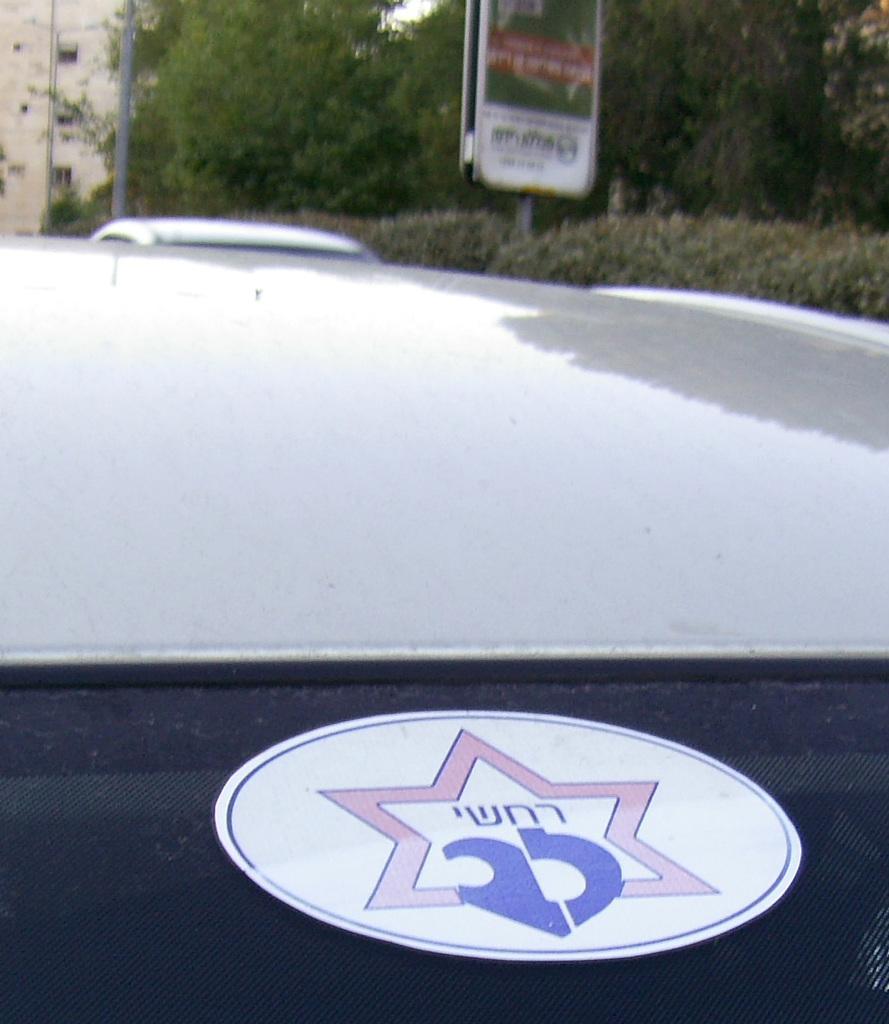How would you summarize this image in a sentence or two? In front of the picture, we see a car. We see a sticker in white, pink and blue color is pasted on the glass of the car. Behind that, we see a white car. Behind that, we see the shrubs and a hoarding board in white and green color. In the background, we see a building, poles and trees. This picture is blurred in the background. 